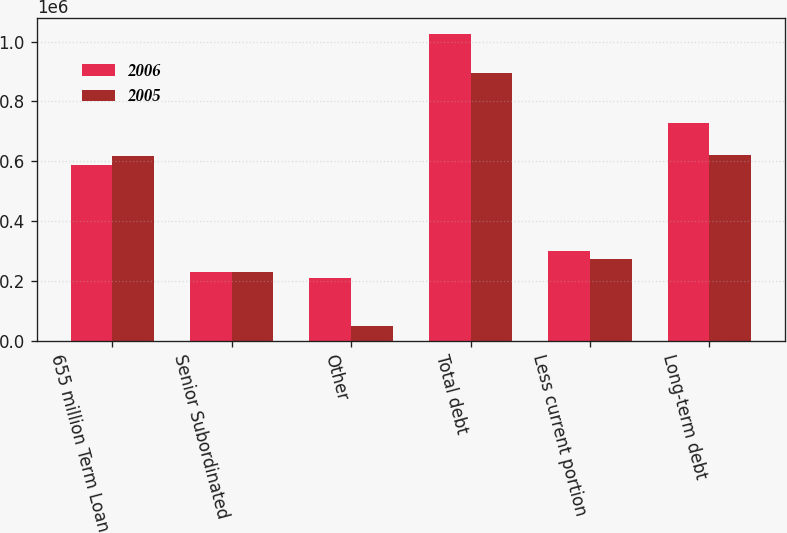Convert chart. <chart><loc_0><loc_0><loc_500><loc_500><stacked_bar_chart><ecel><fcel>655 million Term Loan<fcel>Senior Subordinated<fcel>Other<fcel>Total debt<fcel>Less current portion<fcel>Long-term debt<nl><fcel>2006<fcel>588766<fcel>230000<fcel>208026<fcel>1.02679e+06<fcel>299911<fcel>726881<nl><fcel>2005<fcel>616770<fcel>230000<fcel>47501<fcel>894271<fcel>273313<fcel>620958<nl></chart> 